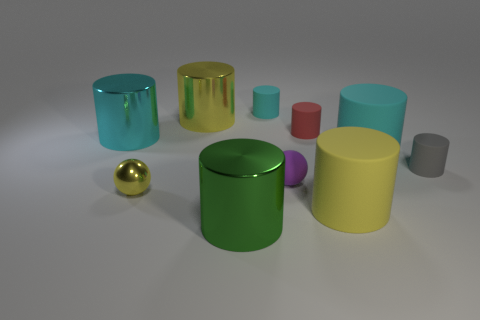There is a sphere that is to the left of the small cyan rubber cylinder behind the tiny red rubber object; what color is it?
Offer a very short reply. Yellow. Is the color of the tiny rubber cylinder that is behind the small red rubber object the same as the metal sphere?
Provide a short and direct response. No. Is the gray rubber cylinder the same size as the green cylinder?
Provide a short and direct response. No. The yellow rubber object that is the same size as the green metal cylinder is what shape?
Offer a terse response. Cylinder. There is a yellow shiny thing behind the gray matte cylinder; is its size the same as the gray cylinder?
Your answer should be very brief. No. There is a purple sphere that is the same size as the gray thing; what material is it?
Offer a terse response. Rubber. There is a yellow cylinder right of the large metal cylinder that is in front of the metallic sphere; is there a yellow ball on the right side of it?
Provide a short and direct response. No. Is there anything else that is the same shape as the large cyan metal object?
Provide a succinct answer. Yes. There is a rubber cylinder that is in front of the small matte sphere; is its color the same as the sphere to the right of the small cyan matte cylinder?
Make the answer very short. No. Is there a large red block?
Your response must be concise. No. 